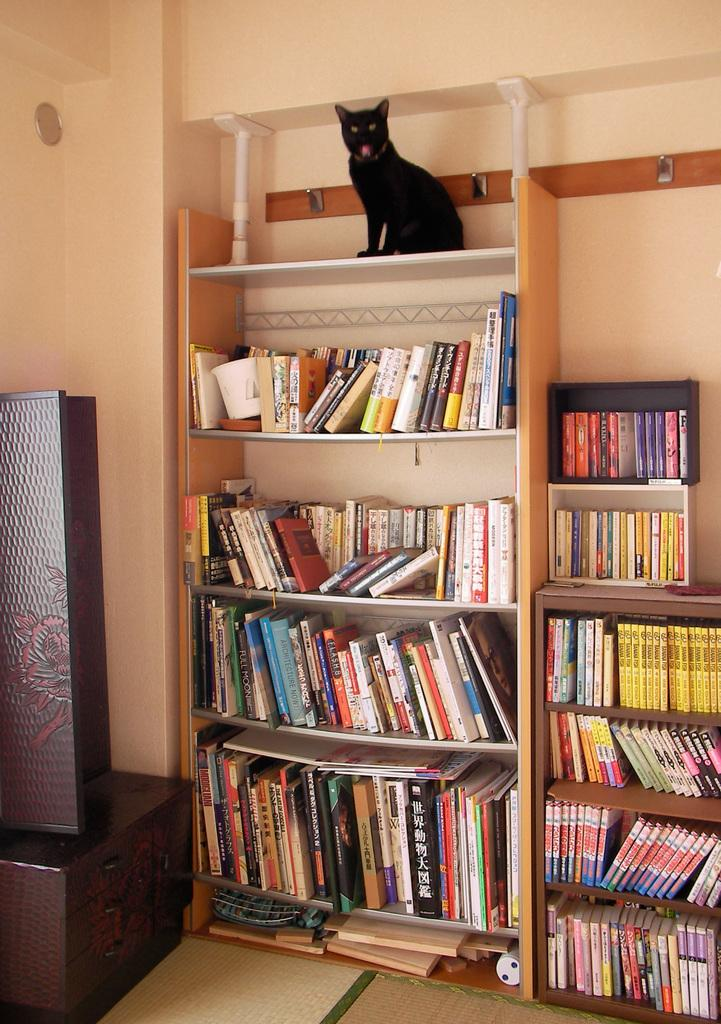What type of animal can be seen in the picture? There is a black cat in the picture. Where is the cat located in the image? The cat is sitting on a shelf. What is the main feature in the center of the image? There are many books in the center of the image. How are the books arranged in the image? The books are kept on wooden racks. What can be seen on the left side of the image? There is a door and a cupboard on the left side of the image. What type of leaf can be seen falling from the ceiling in the image? There is no leaf falling from the ceiling in the image. What flavor of mint is being used to clean the books in the image? There is no mint or cleaning activity involving mint in the image. 